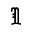Convert formula to latex. <formula><loc_0><loc_0><loc_500><loc_500>\Im</formula> 